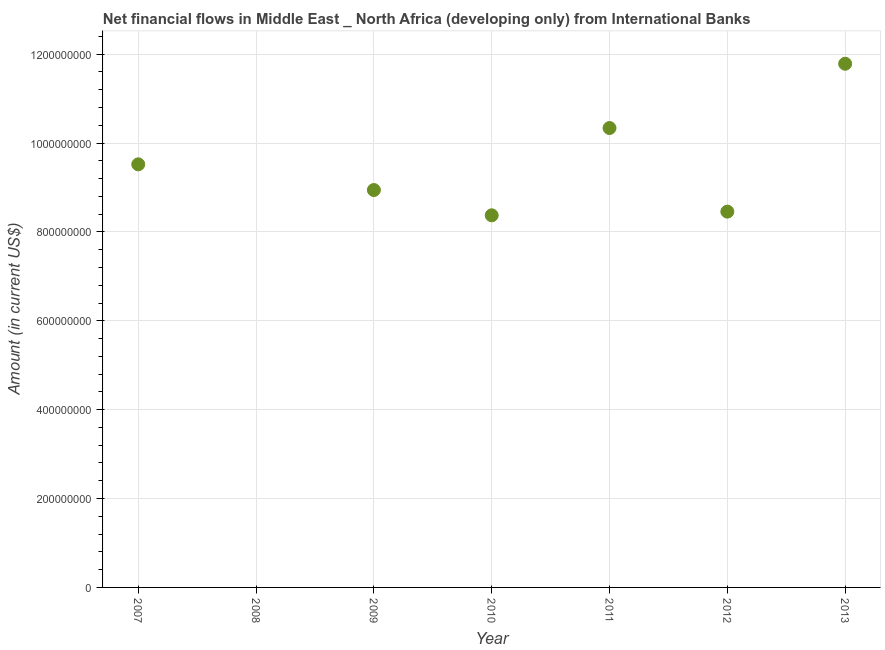What is the net financial flows from ibrd in 2012?
Provide a succinct answer. 8.46e+08. Across all years, what is the maximum net financial flows from ibrd?
Your response must be concise. 1.18e+09. Across all years, what is the minimum net financial flows from ibrd?
Make the answer very short. 0. What is the sum of the net financial flows from ibrd?
Provide a short and direct response. 5.74e+09. What is the difference between the net financial flows from ibrd in 2012 and 2013?
Your answer should be compact. -3.33e+08. What is the average net financial flows from ibrd per year?
Give a very brief answer. 8.20e+08. What is the median net financial flows from ibrd?
Offer a terse response. 8.94e+08. In how many years, is the net financial flows from ibrd greater than 160000000 US$?
Your answer should be very brief. 6. What is the ratio of the net financial flows from ibrd in 2009 to that in 2010?
Provide a succinct answer. 1.07. What is the difference between the highest and the second highest net financial flows from ibrd?
Provide a short and direct response. 1.45e+08. What is the difference between the highest and the lowest net financial flows from ibrd?
Your answer should be very brief. 1.18e+09. In how many years, is the net financial flows from ibrd greater than the average net financial flows from ibrd taken over all years?
Ensure brevity in your answer.  6. What is the difference between two consecutive major ticks on the Y-axis?
Ensure brevity in your answer.  2.00e+08. Does the graph contain any zero values?
Make the answer very short. Yes. What is the title of the graph?
Offer a very short reply. Net financial flows in Middle East _ North Africa (developing only) from International Banks. What is the label or title of the Y-axis?
Make the answer very short. Amount (in current US$). What is the Amount (in current US$) in 2007?
Make the answer very short. 9.52e+08. What is the Amount (in current US$) in 2009?
Ensure brevity in your answer.  8.94e+08. What is the Amount (in current US$) in 2010?
Make the answer very short. 8.37e+08. What is the Amount (in current US$) in 2011?
Make the answer very short. 1.03e+09. What is the Amount (in current US$) in 2012?
Give a very brief answer. 8.46e+08. What is the Amount (in current US$) in 2013?
Provide a short and direct response. 1.18e+09. What is the difference between the Amount (in current US$) in 2007 and 2009?
Provide a short and direct response. 5.78e+07. What is the difference between the Amount (in current US$) in 2007 and 2010?
Provide a short and direct response. 1.15e+08. What is the difference between the Amount (in current US$) in 2007 and 2011?
Offer a terse response. -8.17e+07. What is the difference between the Amount (in current US$) in 2007 and 2012?
Offer a very short reply. 1.06e+08. What is the difference between the Amount (in current US$) in 2007 and 2013?
Your answer should be very brief. -2.26e+08. What is the difference between the Amount (in current US$) in 2009 and 2010?
Provide a short and direct response. 5.69e+07. What is the difference between the Amount (in current US$) in 2009 and 2011?
Offer a terse response. -1.40e+08. What is the difference between the Amount (in current US$) in 2009 and 2012?
Keep it short and to the point. 4.86e+07. What is the difference between the Amount (in current US$) in 2009 and 2013?
Make the answer very short. -2.84e+08. What is the difference between the Amount (in current US$) in 2010 and 2011?
Your response must be concise. -1.96e+08. What is the difference between the Amount (in current US$) in 2010 and 2012?
Offer a terse response. -8.30e+06. What is the difference between the Amount (in current US$) in 2010 and 2013?
Make the answer very short. -3.41e+08. What is the difference between the Amount (in current US$) in 2011 and 2012?
Make the answer very short. 1.88e+08. What is the difference between the Amount (in current US$) in 2011 and 2013?
Keep it short and to the point. -1.45e+08. What is the difference between the Amount (in current US$) in 2012 and 2013?
Give a very brief answer. -3.33e+08. What is the ratio of the Amount (in current US$) in 2007 to that in 2009?
Give a very brief answer. 1.06. What is the ratio of the Amount (in current US$) in 2007 to that in 2010?
Your response must be concise. 1.14. What is the ratio of the Amount (in current US$) in 2007 to that in 2011?
Your response must be concise. 0.92. What is the ratio of the Amount (in current US$) in 2007 to that in 2012?
Provide a succinct answer. 1.13. What is the ratio of the Amount (in current US$) in 2007 to that in 2013?
Offer a very short reply. 0.81. What is the ratio of the Amount (in current US$) in 2009 to that in 2010?
Provide a succinct answer. 1.07. What is the ratio of the Amount (in current US$) in 2009 to that in 2011?
Offer a terse response. 0.86. What is the ratio of the Amount (in current US$) in 2009 to that in 2012?
Keep it short and to the point. 1.06. What is the ratio of the Amount (in current US$) in 2009 to that in 2013?
Offer a terse response. 0.76. What is the ratio of the Amount (in current US$) in 2010 to that in 2011?
Your answer should be compact. 0.81. What is the ratio of the Amount (in current US$) in 2010 to that in 2012?
Keep it short and to the point. 0.99. What is the ratio of the Amount (in current US$) in 2010 to that in 2013?
Make the answer very short. 0.71. What is the ratio of the Amount (in current US$) in 2011 to that in 2012?
Make the answer very short. 1.22. What is the ratio of the Amount (in current US$) in 2011 to that in 2013?
Ensure brevity in your answer.  0.88. What is the ratio of the Amount (in current US$) in 2012 to that in 2013?
Ensure brevity in your answer.  0.72. 